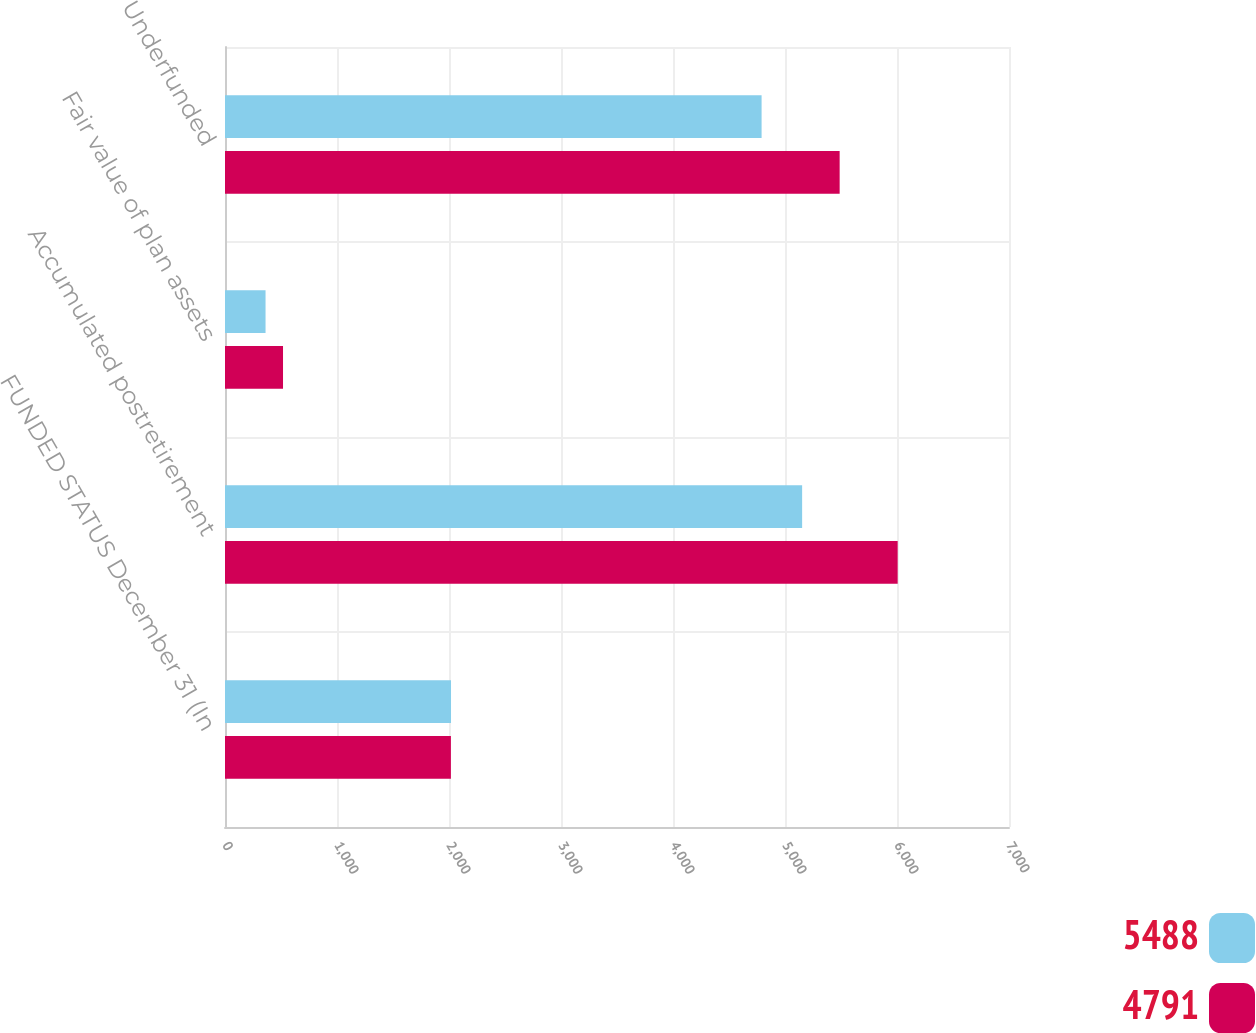Convert chart to OTSL. <chart><loc_0><loc_0><loc_500><loc_500><stacked_bar_chart><ecel><fcel>FUNDED STATUS December 31 (In<fcel>Accumulated postretirement<fcel>Fair value of plan assets<fcel>Underfunded<nl><fcel>5488<fcel>2018<fcel>5153<fcel>362<fcel>4791<nl><fcel>4791<fcel>2017<fcel>6006<fcel>518<fcel>5488<nl></chart> 